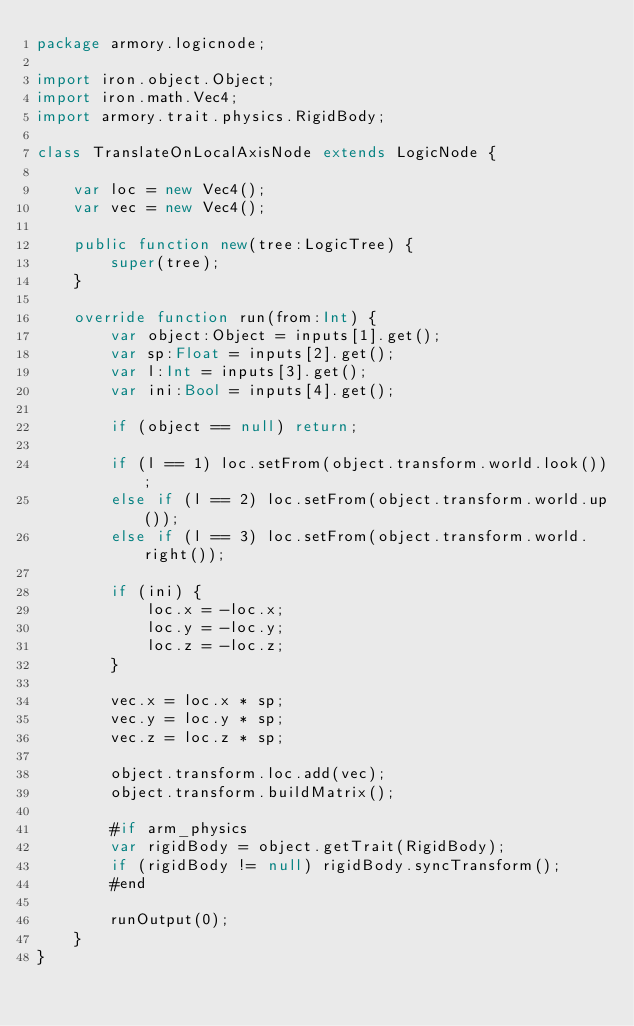Convert code to text. <code><loc_0><loc_0><loc_500><loc_500><_Haxe_>package armory.logicnode;

import iron.object.Object;
import iron.math.Vec4;
import armory.trait.physics.RigidBody;

class TranslateOnLocalAxisNode extends LogicNode {

	var loc = new Vec4();
	var vec = new Vec4();

	public function new(tree:LogicTree) {
		super(tree);
	}

	override function run(from:Int) {
		var object:Object = inputs[1].get();
		var sp:Float = inputs[2].get();
		var l:Int = inputs[3].get();
		var ini:Bool = inputs[4].get();

		if (object == null) return;

		if (l == 1) loc.setFrom(object.transform.world.look());
		else if (l == 2) loc.setFrom(object.transform.world.up());
		else if (l == 3) loc.setFrom(object.transform.world.right());
			
		if (ini) {
			loc.x = -loc.x;
			loc.y = -loc.y;
			loc.z = -loc.z;
		}	
						
		vec.x = loc.x * sp;
		vec.y = loc.y * sp;
		vec.z = loc.z * sp;
		
		object.transform.loc.add(vec);
		object.transform.buildMatrix();
		
		#if arm_physics
		var rigidBody = object.getTrait(RigidBody);
		if (rigidBody != null) rigidBody.syncTransform();
		#end

		runOutput(0);
	}
}
</code> 